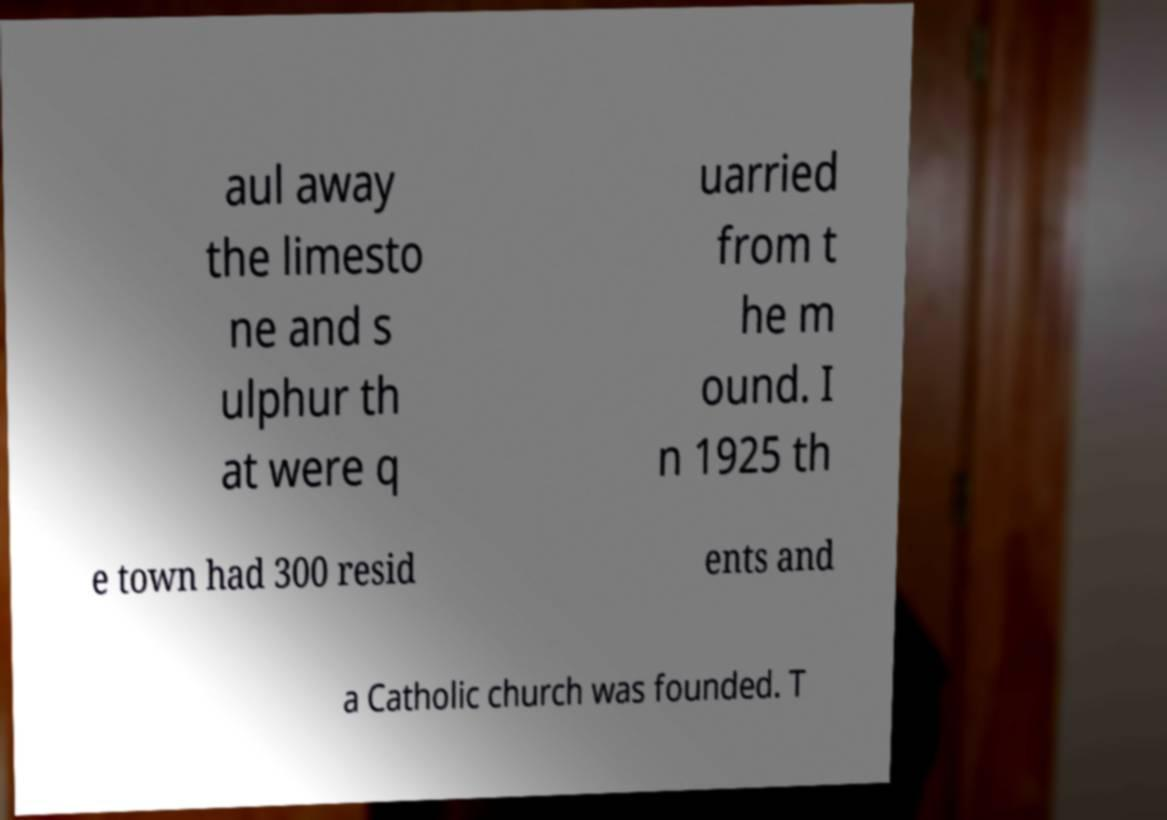Could you assist in decoding the text presented in this image and type it out clearly? aul away the limesto ne and s ulphur th at were q uarried from t he m ound. I n 1925 th e town had 300 resid ents and a Catholic church was founded. T 